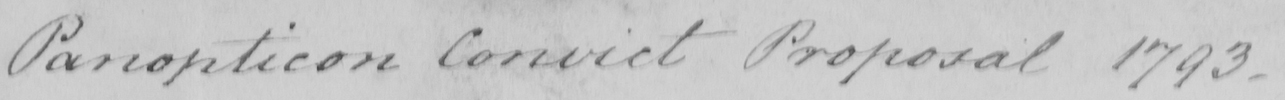Please transcribe the handwritten text in this image. Panopticon Convict Proposal 1793 . 